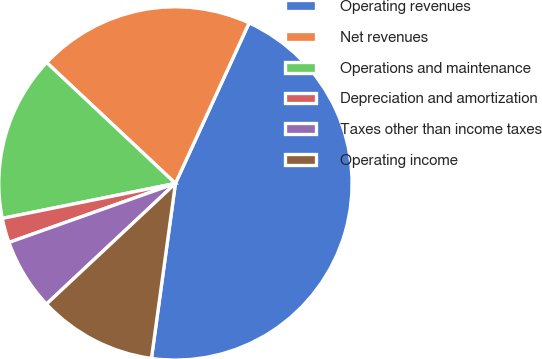Convert chart. <chart><loc_0><loc_0><loc_500><loc_500><pie_chart><fcel>Operating revenues<fcel>Net revenues<fcel>Operations and maintenance<fcel>Depreciation and amortization<fcel>Taxes other than income taxes<fcel>Operating income<nl><fcel>45.32%<fcel>19.85%<fcel>15.17%<fcel>2.25%<fcel>6.55%<fcel>10.86%<nl></chart> 